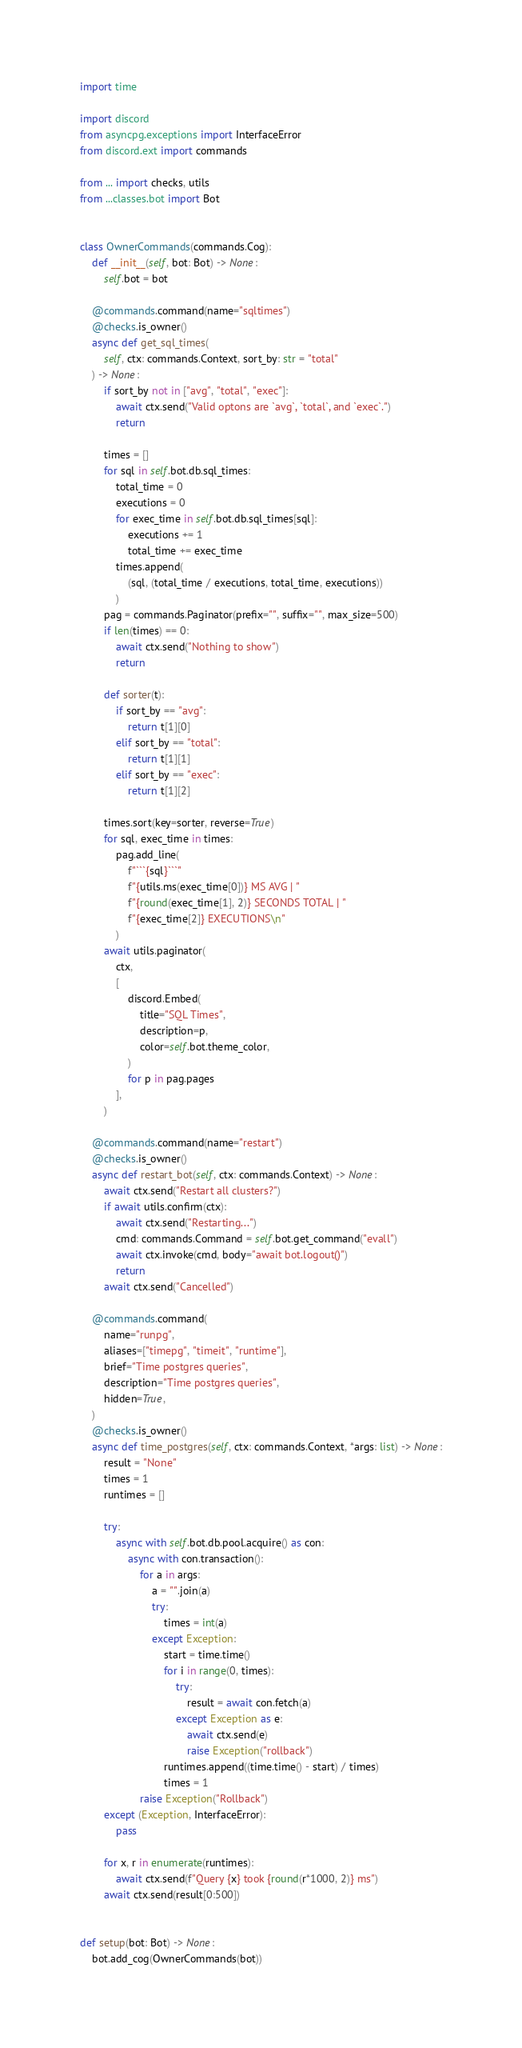<code> <loc_0><loc_0><loc_500><loc_500><_Python_>import time

import discord
from asyncpg.exceptions import InterfaceError
from discord.ext import commands

from ... import checks, utils
from ...classes.bot import Bot


class OwnerCommands(commands.Cog):
    def __init__(self, bot: Bot) -> None:
        self.bot = bot

    @commands.command(name="sqltimes")
    @checks.is_owner()
    async def get_sql_times(
        self, ctx: commands.Context, sort_by: str = "total"
    ) -> None:
        if sort_by not in ["avg", "total", "exec"]:
            await ctx.send("Valid optons are `avg`, `total`, and `exec`.")
            return

        times = []
        for sql in self.bot.db.sql_times:
            total_time = 0
            executions = 0
            for exec_time in self.bot.db.sql_times[sql]:
                executions += 1
                total_time += exec_time
            times.append(
                (sql, (total_time / executions, total_time, executions))
            )
        pag = commands.Paginator(prefix="", suffix="", max_size=500)
        if len(times) == 0:
            await ctx.send("Nothing to show")
            return

        def sorter(t):
            if sort_by == "avg":
                return t[1][0]
            elif sort_by == "total":
                return t[1][1]
            elif sort_by == "exec":
                return t[1][2]

        times.sort(key=sorter, reverse=True)
        for sql, exec_time in times:
            pag.add_line(
                f"```{sql}```"
                f"{utils.ms(exec_time[0])} MS AVG | "
                f"{round(exec_time[1], 2)} SECONDS TOTAL | "
                f"{exec_time[2]} EXECUTIONS\n"
            )
        await utils.paginator(
            ctx,
            [
                discord.Embed(
                    title="SQL Times",
                    description=p,
                    color=self.bot.theme_color,
                )
                for p in pag.pages
            ],
        )

    @commands.command(name="restart")
    @checks.is_owner()
    async def restart_bot(self, ctx: commands.Context) -> None:
        await ctx.send("Restart all clusters?")
        if await utils.confirm(ctx):
            await ctx.send("Restarting...")
            cmd: commands.Command = self.bot.get_command("evall")
            await ctx.invoke(cmd, body="await bot.logout()")
            return
        await ctx.send("Cancelled")

    @commands.command(
        name="runpg",
        aliases=["timepg", "timeit", "runtime"],
        brief="Time postgres queries",
        description="Time postgres queries",
        hidden=True,
    )
    @checks.is_owner()
    async def time_postgres(self, ctx: commands.Context, *args: list) -> None:
        result = "None"
        times = 1
        runtimes = []

        try:
            async with self.bot.db.pool.acquire() as con:
                async with con.transaction():
                    for a in args:
                        a = "".join(a)
                        try:
                            times = int(a)
                        except Exception:
                            start = time.time()
                            for i in range(0, times):
                                try:
                                    result = await con.fetch(a)
                                except Exception as e:
                                    await ctx.send(e)
                                    raise Exception("rollback")
                            runtimes.append((time.time() - start) / times)
                            times = 1
                    raise Exception("Rollback")
        except (Exception, InterfaceError):
            pass

        for x, r in enumerate(runtimes):
            await ctx.send(f"Query {x} took {round(r*1000, 2)} ms")
        await ctx.send(result[0:500])


def setup(bot: Bot) -> None:
    bot.add_cog(OwnerCommands(bot))
</code> 